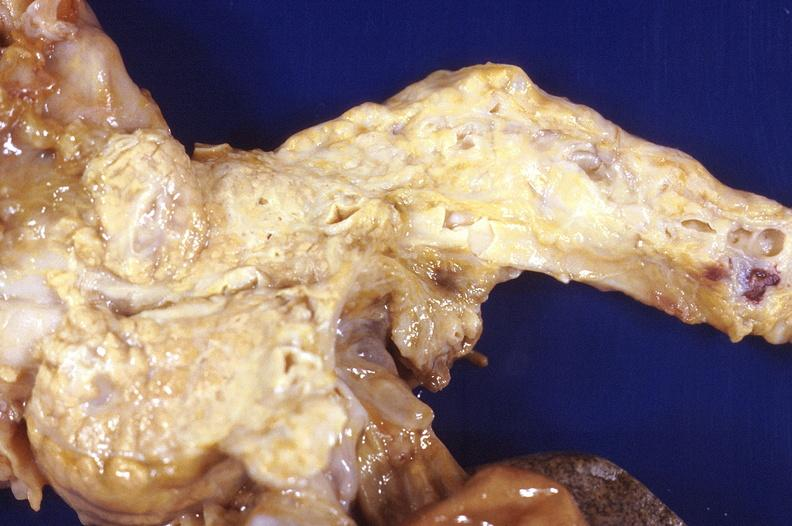what does this image show?
Answer the question using a single word or phrase. Prostatic hyperplasia 